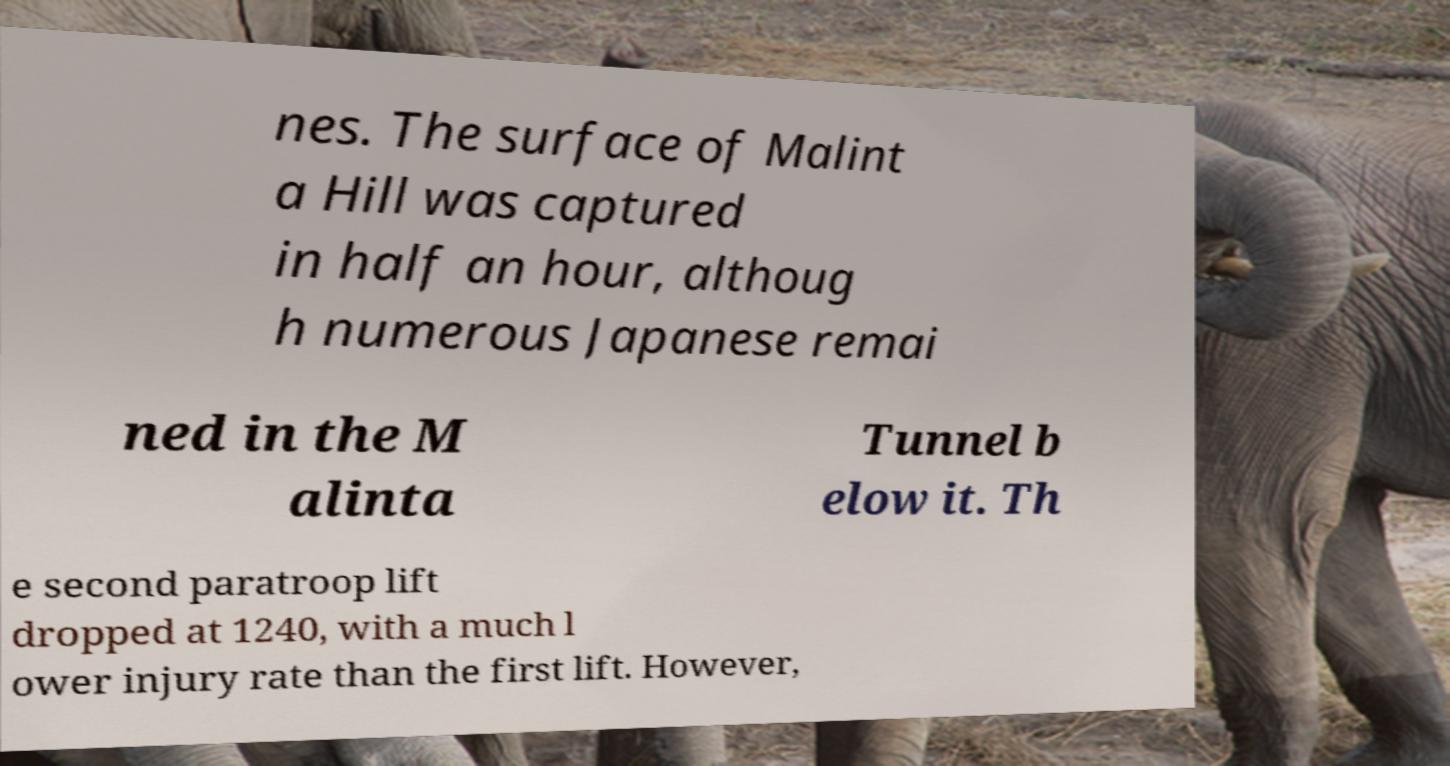Please read and relay the text visible in this image. What does it say? nes. The surface of Malint a Hill was captured in half an hour, althoug h numerous Japanese remai ned in the M alinta Tunnel b elow it. Th e second paratroop lift dropped at 1240, with a much l ower injury rate than the first lift. However, 